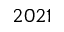<formula> <loc_0><loc_0><loc_500><loc_500>2 0 2 1</formula> 